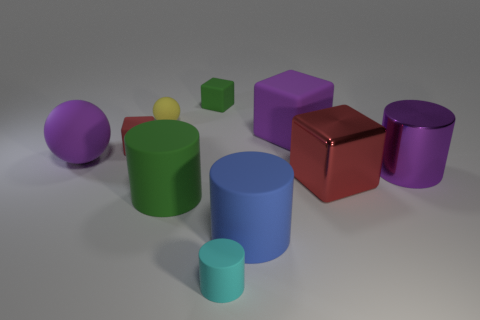Are there any gray blocks?
Provide a short and direct response. No. What shape is the big green object that is the same material as the blue cylinder?
Your answer should be very brief. Cylinder. There is a cyan object; is its shape the same as the purple object that is left of the red matte block?
Provide a succinct answer. No. What material is the red cube that is in front of the red object that is on the left side of the cyan matte cylinder made of?
Keep it short and to the point. Metal. How many other things are the same shape as the small cyan matte object?
Your answer should be compact. 3. Is the shape of the large metallic thing that is to the left of the big purple metal thing the same as the big purple matte thing left of the cyan cylinder?
Give a very brief answer. No. Is there anything else that has the same material as the yellow thing?
Ensure brevity in your answer.  Yes. What material is the large sphere?
Ensure brevity in your answer.  Rubber. What material is the red block that is in front of the large purple metallic cylinder?
Keep it short and to the point. Metal. Are there any other things of the same color as the large matte cube?
Your answer should be very brief. Yes. 